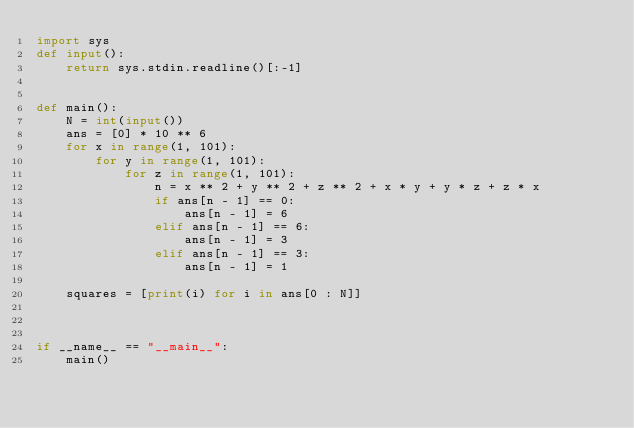<code> <loc_0><loc_0><loc_500><loc_500><_Python_>import sys
def input():
    return sys.stdin.readline()[:-1]


def main():
    N = int(input())
    ans = [0] * 10 ** 6
    for x in range(1, 101):
        for y in range(1, 101):
            for z in range(1, 101):
                n = x ** 2 + y ** 2 + z ** 2 + x * y + y * z + z * x
                if ans[n - 1] == 0:
                    ans[n - 1] = 6
                elif ans[n - 1] == 6:
                    ans[n - 1] = 3
                elif ans[n - 1] == 3:
                    ans[n - 1] = 1

    squares = [print(i) for i in ans[0 : N]]

                    
    
if __name__ == "__main__":
    main()</code> 